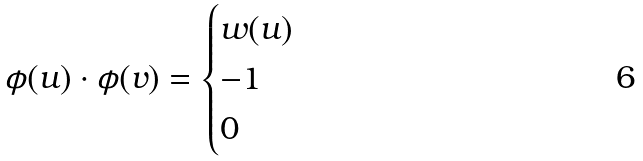<formula> <loc_0><loc_0><loc_500><loc_500>\phi ( u ) \cdot \phi ( v ) = \begin{cases} w ( u ) & \\ - 1 & \\ 0 & \end{cases}</formula> 